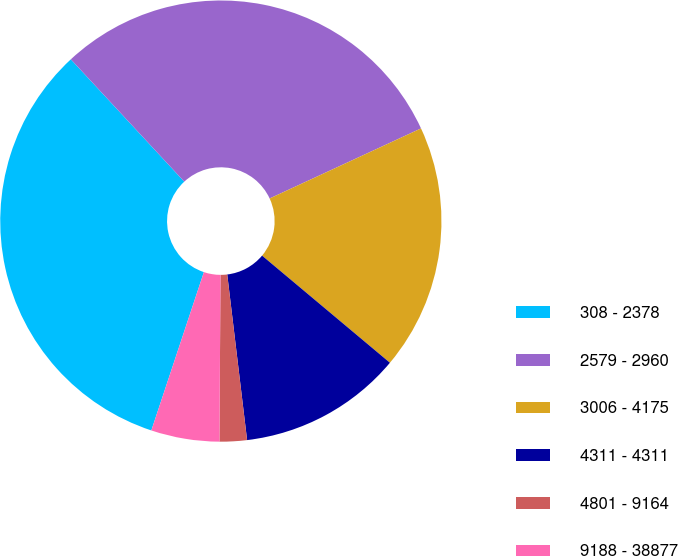Convert chart to OTSL. <chart><loc_0><loc_0><loc_500><loc_500><pie_chart><fcel>308 - 2378<fcel>2579 - 2960<fcel>3006 - 4175<fcel>4311 - 4311<fcel>4801 - 9164<fcel>9188 - 38877<nl><fcel>33.0%<fcel>30.0%<fcel>18.0%<fcel>12.0%<fcel>2.0%<fcel>5.0%<nl></chart> 